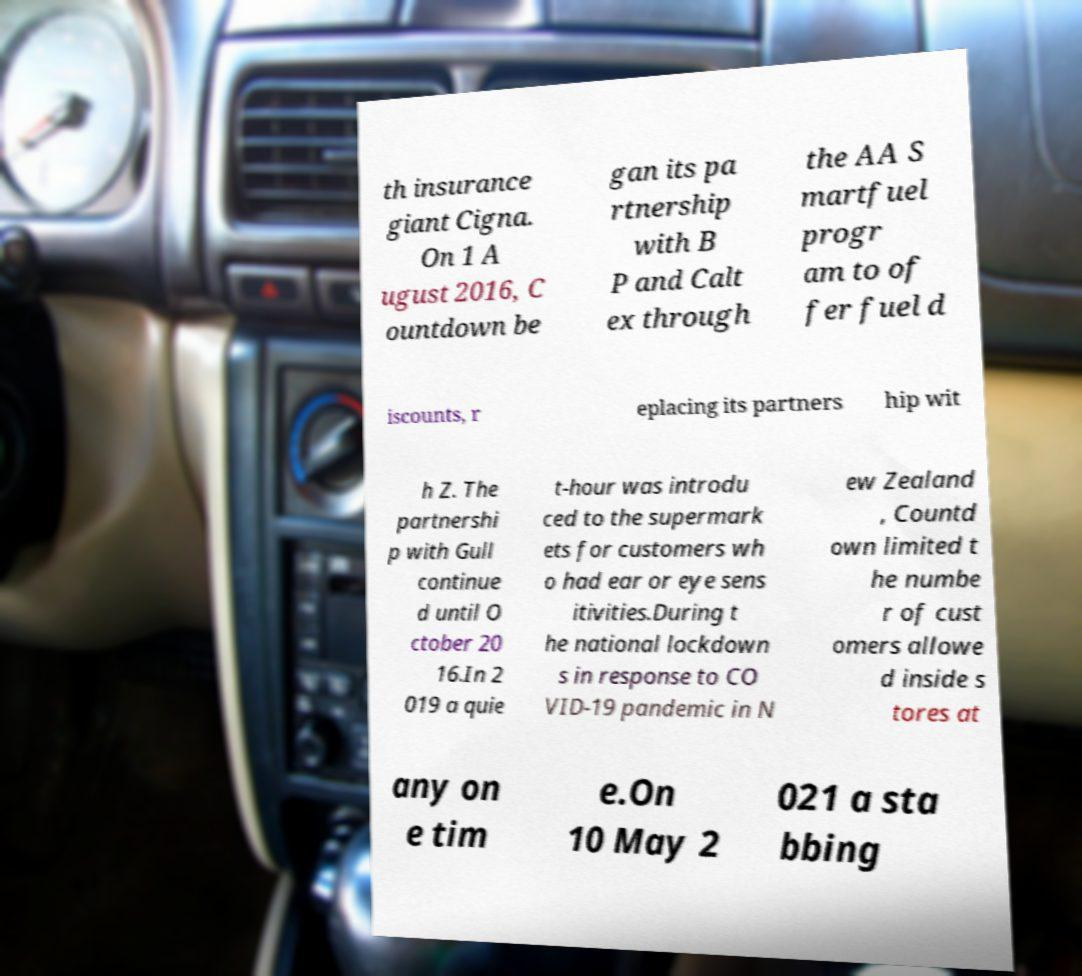Please read and relay the text visible in this image. What does it say? th insurance giant Cigna. On 1 A ugust 2016, C ountdown be gan its pa rtnership with B P and Calt ex through the AA S martfuel progr am to of fer fuel d iscounts, r eplacing its partners hip wit h Z. The partnershi p with Gull continue d until O ctober 20 16.In 2 019 a quie t-hour was introdu ced to the supermark ets for customers wh o had ear or eye sens itivities.During t he national lockdown s in response to CO VID-19 pandemic in N ew Zealand , Countd own limited t he numbe r of cust omers allowe d inside s tores at any on e tim e.On 10 May 2 021 a sta bbing 